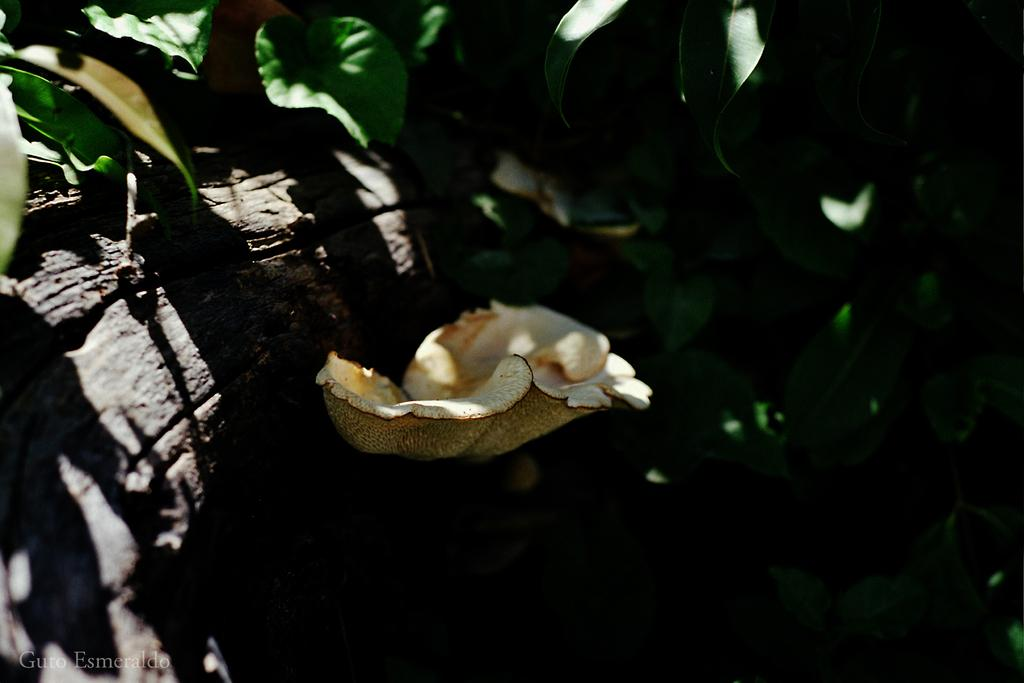What is the main subject in the center of the image? There is a mushroom in the center of the image. What can be seen in the background of the image? There are leaves in the background of the image. What type of offer is the mushroom making to the son in the image? There is no son or offer present in the image; it only features a mushroom and leaves. 